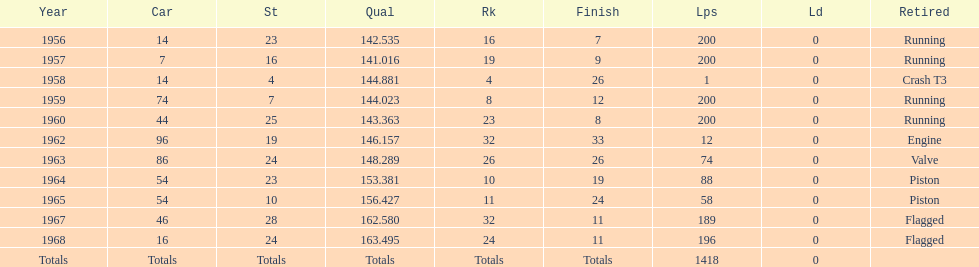Did bob veith drive more indy 500 laps in the 1950s or 1960s? 1960s. 